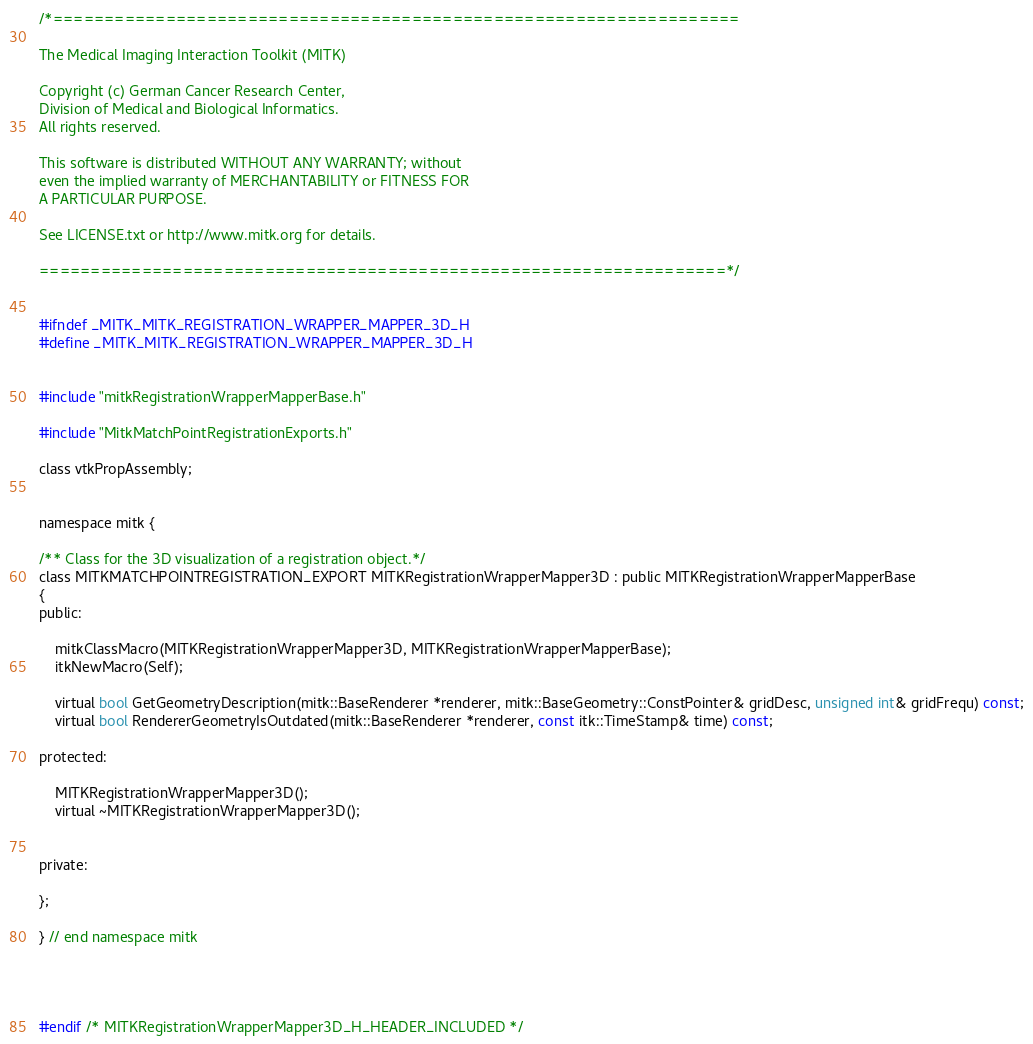<code> <loc_0><loc_0><loc_500><loc_500><_C_>/*===================================================================

The Medical Imaging Interaction Toolkit (MITK)

Copyright (c) German Cancer Research Center,
Division of Medical and Biological Informatics.
All rights reserved.

This software is distributed WITHOUT ANY WARRANTY; without
even the implied warranty of MERCHANTABILITY or FITNESS FOR
A PARTICULAR PURPOSE.

See LICENSE.txt or http://www.mitk.org for details.

===================================================================*/


#ifndef _MITK_MITK_REGISTRATION_WRAPPER_MAPPER_3D_H
#define _MITK_MITK_REGISTRATION_WRAPPER_MAPPER_3D_H


#include "mitkRegistrationWrapperMapperBase.h"

#include "MitkMatchPointRegistrationExports.h"

class vtkPropAssembly;


namespace mitk {

/** Class for the 3D visualization of a registration object.*/
class MITKMATCHPOINTREGISTRATION_EXPORT MITKRegistrationWrapperMapper3D : public MITKRegistrationWrapperMapperBase
{
public:

    mitkClassMacro(MITKRegistrationWrapperMapper3D, MITKRegistrationWrapperMapperBase);
    itkNewMacro(Self);

    virtual bool GetGeometryDescription(mitk::BaseRenderer *renderer, mitk::BaseGeometry::ConstPointer& gridDesc, unsigned int& gridFrequ) const;
    virtual bool RendererGeometryIsOutdated(mitk::BaseRenderer *renderer, const itk::TimeStamp& time) const;

protected:

    MITKRegistrationWrapperMapper3D();
    virtual ~MITKRegistrationWrapperMapper3D();


private:

};

} // end namespace mitk




#endif /* MITKRegistrationWrapperMapper3D_H_HEADER_INCLUDED */

</code> 